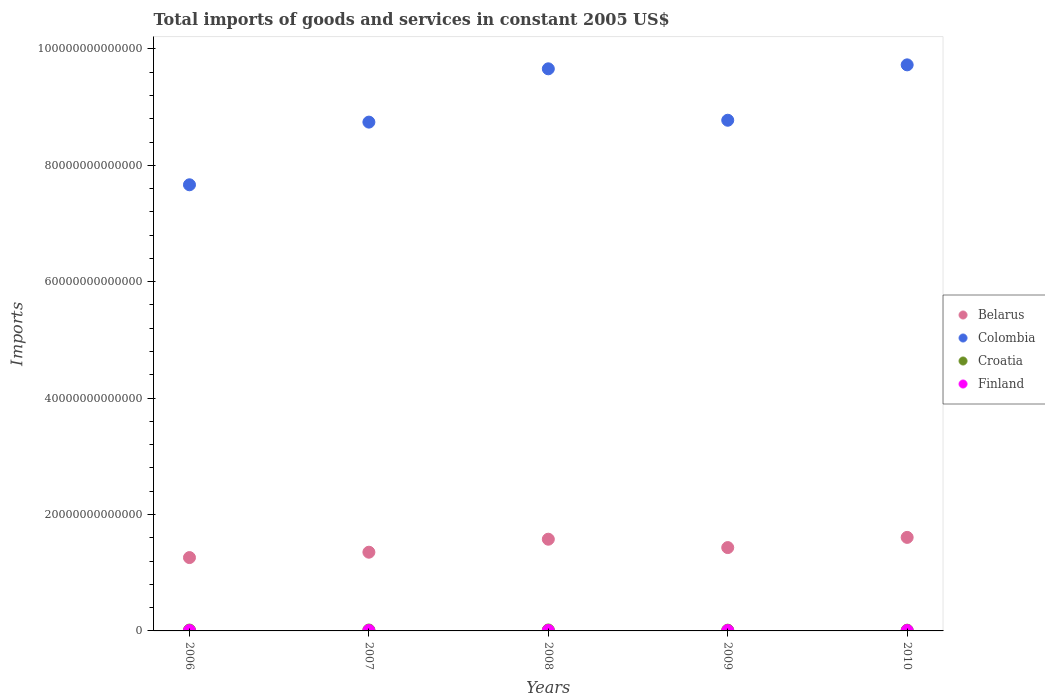What is the total imports of goods and services in Colombia in 2007?
Your answer should be very brief. 8.74e+13. Across all years, what is the maximum total imports of goods and services in Belarus?
Provide a short and direct response. 1.61e+13. Across all years, what is the minimum total imports of goods and services in Croatia?
Offer a very short reply. 1.25e+11. In which year was the total imports of goods and services in Croatia minimum?
Your response must be concise. 2010. What is the total total imports of goods and services in Finland in the graph?
Make the answer very short. 3.56e+11. What is the difference between the total imports of goods and services in Belarus in 2007 and that in 2009?
Offer a terse response. -7.94e+11. What is the difference between the total imports of goods and services in Croatia in 2010 and the total imports of goods and services in Finland in 2007?
Offer a very short reply. 5.19e+1. What is the average total imports of goods and services in Finland per year?
Offer a very short reply. 7.12e+1. In the year 2010, what is the difference between the total imports of goods and services in Belarus and total imports of goods and services in Colombia?
Give a very brief answer. -8.12e+13. In how many years, is the total imports of goods and services in Croatia greater than 68000000000000 US$?
Provide a succinct answer. 0. What is the ratio of the total imports of goods and services in Belarus in 2007 to that in 2010?
Your response must be concise. 0.84. Is the difference between the total imports of goods and services in Belarus in 2006 and 2008 greater than the difference between the total imports of goods and services in Colombia in 2006 and 2008?
Ensure brevity in your answer.  Yes. What is the difference between the highest and the second highest total imports of goods and services in Finland?
Keep it short and to the point. 5.80e+09. What is the difference between the highest and the lowest total imports of goods and services in Croatia?
Provide a succinct answer. 3.60e+1. Is the sum of the total imports of goods and services in Finland in 2006 and 2010 greater than the maximum total imports of goods and services in Croatia across all years?
Provide a succinct answer. No. Is it the case that in every year, the sum of the total imports of goods and services in Croatia and total imports of goods and services in Belarus  is greater than the total imports of goods and services in Colombia?
Give a very brief answer. No. Is the total imports of goods and services in Colombia strictly greater than the total imports of goods and services in Belarus over the years?
Keep it short and to the point. Yes. Is the total imports of goods and services in Croatia strictly less than the total imports of goods and services in Finland over the years?
Your answer should be very brief. No. How many years are there in the graph?
Keep it short and to the point. 5. What is the difference between two consecutive major ticks on the Y-axis?
Provide a succinct answer. 2.00e+13. Are the values on the major ticks of Y-axis written in scientific E-notation?
Your answer should be very brief. No. Does the graph contain grids?
Provide a succinct answer. No. What is the title of the graph?
Offer a terse response. Total imports of goods and services in constant 2005 US$. Does "Trinidad and Tobago" appear as one of the legend labels in the graph?
Offer a terse response. No. What is the label or title of the X-axis?
Your answer should be very brief. Years. What is the label or title of the Y-axis?
Provide a succinct answer. Imports. What is the Imports of Belarus in 2006?
Offer a very short reply. 1.26e+13. What is the Imports in Colombia in 2006?
Make the answer very short. 7.67e+13. What is the Imports of Croatia in 2006?
Offer a terse response. 1.46e+11. What is the Imports of Finland in 2006?
Offer a terse response. 6.82e+1. What is the Imports of Belarus in 2007?
Keep it short and to the point. 1.35e+13. What is the Imports in Colombia in 2007?
Your response must be concise. 8.74e+13. What is the Imports of Croatia in 2007?
Your answer should be compact. 1.55e+11. What is the Imports in Finland in 2007?
Your answer should be very brief. 7.32e+1. What is the Imports of Belarus in 2008?
Offer a terse response. 1.58e+13. What is the Imports of Colombia in 2008?
Offer a terse response. 9.66e+13. What is the Imports in Croatia in 2008?
Your answer should be very brief. 1.61e+11. What is the Imports of Finland in 2008?
Make the answer very short. 7.90e+1. What is the Imports of Belarus in 2009?
Ensure brevity in your answer.  1.43e+13. What is the Imports of Colombia in 2009?
Provide a short and direct response. 8.77e+13. What is the Imports of Croatia in 2009?
Provide a succinct answer. 1.28e+11. What is the Imports of Finland in 2009?
Make the answer very short. 6.57e+1. What is the Imports of Belarus in 2010?
Provide a short and direct response. 1.61e+13. What is the Imports in Colombia in 2010?
Ensure brevity in your answer.  9.73e+13. What is the Imports of Croatia in 2010?
Your response must be concise. 1.25e+11. What is the Imports of Finland in 2010?
Provide a succinct answer. 7.00e+1. Across all years, what is the maximum Imports in Belarus?
Make the answer very short. 1.61e+13. Across all years, what is the maximum Imports of Colombia?
Provide a succinct answer. 9.73e+13. Across all years, what is the maximum Imports in Croatia?
Ensure brevity in your answer.  1.61e+11. Across all years, what is the maximum Imports in Finland?
Your response must be concise. 7.90e+1. Across all years, what is the minimum Imports of Belarus?
Your answer should be very brief. 1.26e+13. Across all years, what is the minimum Imports in Colombia?
Offer a terse response. 7.67e+13. Across all years, what is the minimum Imports in Croatia?
Your answer should be very brief. 1.25e+11. Across all years, what is the minimum Imports of Finland?
Make the answer very short. 6.57e+1. What is the total Imports of Belarus in the graph?
Give a very brief answer. 7.23e+13. What is the total Imports in Colombia in the graph?
Provide a short and direct response. 4.46e+14. What is the total Imports in Croatia in the graph?
Your answer should be very brief. 7.16e+11. What is the total Imports in Finland in the graph?
Keep it short and to the point. 3.56e+11. What is the difference between the Imports in Belarus in 2006 and that in 2007?
Make the answer very short. -9.23e+11. What is the difference between the Imports in Colombia in 2006 and that in 2007?
Your answer should be very brief. -1.08e+13. What is the difference between the Imports in Croatia in 2006 and that in 2007?
Give a very brief answer. -8.89e+09. What is the difference between the Imports in Finland in 2006 and that in 2007?
Make the answer very short. -5.05e+09. What is the difference between the Imports in Belarus in 2006 and that in 2008?
Provide a succinct answer. -3.15e+12. What is the difference between the Imports of Colombia in 2006 and that in 2008?
Provide a succinct answer. -1.99e+13. What is the difference between the Imports in Croatia in 2006 and that in 2008?
Provide a succinct answer. -1.50e+1. What is the difference between the Imports of Finland in 2006 and that in 2008?
Give a very brief answer. -1.09e+1. What is the difference between the Imports of Belarus in 2006 and that in 2009?
Ensure brevity in your answer.  -1.72e+12. What is the difference between the Imports of Colombia in 2006 and that in 2009?
Keep it short and to the point. -1.11e+13. What is the difference between the Imports in Croatia in 2006 and that in 2009?
Provide a short and direct response. 1.78e+1. What is the difference between the Imports in Finland in 2006 and that in 2009?
Your answer should be compact. 2.47e+09. What is the difference between the Imports in Belarus in 2006 and that in 2010?
Give a very brief answer. -3.47e+12. What is the difference between the Imports of Colombia in 2006 and that in 2010?
Offer a very short reply. -2.06e+13. What is the difference between the Imports of Croatia in 2006 and that in 2010?
Your response must be concise. 2.10e+1. What is the difference between the Imports in Finland in 2006 and that in 2010?
Make the answer very short. -1.80e+09. What is the difference between the Imports of Belarus in 2007 and that in 2008?
Offer a very short reply. -2.23e+12. What is the difference between the Imports in Colombia in 2007 and that in 2008?
Your answer should be very brief. -9.16e+12. What is the difference between the Imports in Croatia in 2007 and that in 2008?
Give a very brief answer. -6.14e+09. What is the difference between the Imports of Finland in 2007 and that in 2008?
Ensure brevity in your answer.  -5.80e+09. What is the difference between the Imports of Belarus in 2007 and that in 2009?
Make the answer very short. -7.94e+11. What is the difference between the Imports in Colombia in 2007 and that in 2009?
Provide a short and direct response. -3.22e+11. What is the difference between the Imports of Croatia in 2007 and that in 2009?
Your answer should be compact. 2.67e+1. What is the difference between the Imports in Finland in 2007 and that in 2009?
Ensure brevity in your answer.  7.52e+09. What is the difference between the Imports in Belarus in 2007 and that in 2010?
Offer a very short reply. -2.54e+12. What is the difference between the Imports of Colombia in 2007 and that in 2010?
Provide a succinct answer. -9.84e+12. What is the difference between the Imports of Croatia in 2007 and that in 2010?
Your response must be concise. 2.99e+1. What is the difference between the Imports of Finland in 2007 and that in 2010?
Your answer should be compact. 3.24e+09. What is the difference between the Imports of Belarus in 2008 and that in 2009?
Ensure brevity in your answer.  1.44e+12. What is the difference between the Imports of Colombia in 2008 and that in 2009?
Keep it short and to the point. 8.84e+12. What is the difference between the Imports of Croatia in 2008 and that in 2009?
Your answer should be very brief. 3.29e+1. What is the difference between the Imports of Finland in 2008 and that in 2009?
Ensure brevity in your answer.  1.33e+1. What is the difference between the Imports in Belarus in 2008 and that in 2010?
Offer a very short reply. -3.13e+11. What is the difference between the Imports in Colombia in 2008 and that in 2010?
Provide a succinct answer. -6.80e+11. What is the difference between the Imports of Croatia in 2008 and that in 2010?
Provide a short and direct response. 3.60e+1. What is the difference between the Imports of Finland in 2008 and that in 2010?
Offer a terse response. 9.05e+09. What is the difference between the Imports of Belarus in 2009 and that in 2010?
Provide a short and direct response. -1.75e+12. What is the difference between the Imports in Colombia in 2009 and that in 2010?
Your answer should be compact. -9.52e+12. What is the difference between the Imports of Croatia in 2009 and that in 2010?
Ensure brevity in your answer.  3.17e+09. What is the difference between the Imports of Finland in 2009 and that in 2010?
Make the answer very short. -4.27e+09. What is the difference between the Imports in Belarus in 2006 and the Imports in Colombia in 2007?
Offer a very short reply. -7.48e+13. What is the difference between the Imports of Belarus in 2006 and the Imports of Croatia in 2007?
Provide a succinct answer. 1.24e+13. What is the difference between the Imports in Belarus in 2006 and the Imports in Finland in 2007?
Ensure brevity in your answer.  1.25e+13. What is the difference between the Imports of Colombia in 2006 and the Imports of Croatia in 2007?
Give a very brief answer. 7.65e+13. What is the difference between the Imports of Colombia in 2006 and the Imports of Finland in 2007?
Provide a succinct answer. 7.66e+13. What is the difference between the Imports of Croatia in 2006 and the Imports of Finland in 2007?
Your answer should be very brief. 7.30e+1. What is the difference between the Imports in Belarus in 2006 and the Imports in Colombia in 2008?
Keep it short and to the point. -8.40e+13. What is the difference between the Imports of Belarus in 2006 and the Imports of Croatia in 2008?
Your answer should be very brief. 1.24e+13. What is the difference between the Imports of Belarus in 2006 and the Imports of Finland in 2008?
Provide a succinct answer. 1.25e+13. What is the difference between the Imports in Colombia in 2006 and the Imports in Croatia in 2008?
Offer a very short reply. 7.65e+13. What is the difference between the Imports of Colombia in 2006 and the Imports of Finland in 2008?
Provide a succinct answer. 7.66e+13. What is the difference between the Imports in Croatia in 2006 and the Imports in Finland in 2008?
Keep it short and to the point. 6.71e+1. What is the difference between the Imports in Belarus in 2006 and the Imports in Colombia in 2009?
Your answer should be very brief. -7.51e+13. What is the difference between the Imports of Belarus in 2006 and the Imports of Croatia in 2009?
Offer a terse response. 1.25e+13. What is the difference between the Imports in Belarus in 2006 and the Imports in Finland in 2009?
Offer a very short reply. 1.25e+13. What is the difference between the Imports of Colombia in 2006 and the Imports of Croatia in 2009?
Provide a succinct answer. 7.65e+13. What is the difference between the Imports in Colombia in 2006 and the Imports in Finland in 2009?
Make the answer very short. 7.66e+13. What is the difference between the Imports of Croatia in 2006 and the Imports of Finland in 2009?
Provide a succinct answer. 8.05e+1. What is the difference between the Imports of Belarus in 2006 and the Imports of Colombia in 2010?
Offer a terse response. -8.47e+13. What is the difference between the Imports in Belarus in 2006 and the Imports in Croatia in 2010?
Your answer should be compact. 1.25e+13. What is the difference between the Imports in Belarus in 2006 and the Imports in Finland in 2010?
Make the answer very short. 1.25e+13. What is the difference between the Imports in Colombia in 2006 and the Imports in Croatia in 2010?
Give a very brief answer. 7.65e+13. What is the difference between the Imports in Colombia in 2006 and the Imports in Finland in 2010?
Ensure brevity in your answer.  7.66e+13. What is the difference between the Imports in Croatia in 2006 and the Imports in Finland in 2010?
Ensure brevity in your answer.  7.62e+1. What is the difference between the Imports of Belarus in 2007 and the Imports of Colombia in 2008?
Your answer should be very brief. -8.31e+13. What is the difference between the Imports in Belarus in 2007 and the Imports in Croatia in 2008?
Give a very brief answer. 1.34e+13. What is the difference between the Imports in Belarus in 2007 and the Imports in Finland in 2008?
Give a very brief answer. 1.34e+13. What is the difference between the Imports in Colombia in 2007 and the Imports in Croatia in 2008?
Your response must be concise. 8.73e+13. What is the difference between the Imports in Colombia in 2007 and the Imports in Finland in 2008?
Provide a succinct answer. 8.73e+13. What is the difference between the Imports of Croatia in 2007 and the Imports of Finland in 2008?
Give a very brief answer. 7.60e+1. What is the difference between the Imports in Belarus in 2007 and the Imports in Colombia in 2009?
Offer a very short reply. -7.42e+13. What is the difference between the Imports of Belarus in 2007 and the Imports of Croatia in 2009?
Provide a short and direct response. 1.34e+13. What is the difference between the Imports in Belarus in 2007 and the Imports in Finland in 2009?
Provide a short and direct response. 1.35e+13. What is the difference between the Imports of Colombia in 2007 and the Imports of Croatia in 2009?
Keep it short and to the point. 8.73e+13. What is the difference between the Imports in Colombia in 2007 and the Imports in Finland in 2009?
Ensure brevity in your answer.  8.74e+13. What is the difference between the Imports of Croatia in 2007 and the Imports of Finland in 2009?
Make the answer very short. 8.94e+1. What is the difference between the Imports of Belarus in 2007 and the Imports of Colombia in 2010?
Give a very brief answer. -8.37e+13. What is the difference between the Imports in Belarus in 2007 and the Imports in Croatia in 2010?
Provide a succinct answer. 1.34e+13. What is the difference between the Imports in Belarus in 2007 and the Imports in Finland in 2010?
Make the answer very short. 1.35e+13. What is the difference between the Imports of Colombia in 2007 and the Imports of Croatia in 2010?
Provide a succinct answer. 8.73e+13. What is the difference between the Imports in Colombia in 2007 and the Imports in Finland in 2010?
Keep it short and to the point. 8.74e+13. What is the difference between the Imports of Croatia in 2007 and the Imports of Finland in 2010?
Your answer should be compact. 8.51e+1. What is the difference between the Imports of Belarus in 2008 and the Imports of Colombia in 2009?
Keep it short and to the point. -7.20e+13. What is the difference between the Imports in Belarus in 2008 and the Imports in Croatia in 2009?
Offer a very short reply. 1.56e+13. What is the difference between the Imports of Belarus in 2008 and the Imports of Finland in 2009?
Your answer should be compact. 1.57e+13. What is the difference between the Imports in Colombia in 2008 and the Imports in Croatia in 2009?
Your answer should be very brief. 9.65e+13. What is the difference between the Imports of Colombia in 2008 and the Imports of Finland in 2009?
Make the answer very short. 9.65e+13. What is the difference between the Imports in Croatia in 2008 and the Imports in Finland in 2009?
Your answer should be compact. 9.55e+1. What is the difference between the Imports in Belarus in 2008 and the Imports in Colombia in 2010?
Offer a very short reply. -8.15e+13. What is the difference between the Imports of Belarus in 2008 and the Imports of Croatia in 2010?
Your answer should be compact. 1.56e+13. What is the difference between the Imports in Belarus in 2008 and the Imports in Finland in 2010?
Provide a short and direct response. 1.57e+13. What is the difference between the Imports in Colombia in 2008 and the Imports in Croatia in 2010?
Your answer should be very brief. 9.65e+13. What is the difference between the Imports in Colombia in 2008 and the Imports in Finland in 2010?
Your response must be concise. 9.65e+13. What is the difference between the Imports of Croatia in 2008 and the Imports of Finland in 2010?
Offer a very short reply. 9.12e+1. What is the difference between the Imports of Belarus in 2009 and the Imports of Colombia in 2010?
Your answer should be very brief. -8.29e+13. What is the difference between the Imports in Belarus in 2009 and the Imports in Croatia in 2010?
Your answer should be compact. 1.42e+13. What is the difference between the Imports of Belarus in 2009 and the Imports of Finland in 2010?
Keep it short and to the point. 1.42e+13. What is the difference between the Imports in Colombia in 2009 and the Imports in Croatia in 2010?
Your answer should be compact. 8.76e+13. What is the difference between the Imports of Colombia in 2009 and the Imports of Finland in 2010?
Offer a very short reply. 8.77e+13. What is the difference between the Imports of Croatia in 2009 and the Imports of Finland in 2010?
Provide a succinct answer. 5.84e+1. What is the average Imports in Belarus per year?
Ensure brevity in your answer.  1.45e+13. What is the average Imports in Colombia per year?
Keep it short and to the point. 8.91e+13. What is the average Imports of Croatia per year?
Your answer should be compact. 1.43e+11. What is the average Imports of Finland per year?
Provide a short and direct response. 7.12e+1. In the year 2006, what is the difference between the Imports in Belarus and Imports in Colombia?
Provide a short and direct response. -6.41e+13. In the year 2006, what is the difference between the Imports in Belarus and Imports in Croatia?
Your response must be concise. 1.25e+13. In the year 2006, what is the difference between the Imports of Belarus and Imports of Finland?
Provide a succinct answer. 1.25e+13. In the year 2006, what is the difference between the Imports in Colombia and Imports in Croatia?
Provide a short and direct response. 7.65e+13. In the year 2006, what is the difference between the Imports in Colombia and Imports in Finland?
Keep it short and to the point. 7.66e+13. In the year 2006, what is the difference between the Imports of Croatia and Imports of Finland?
Keep it short and to the point. 7.80e+1. In the year 2007, what is the difference between the Imports of Belarus and Imports of Colombia?
Offer a terse response. -7.39e+13. In the year 2007, what is the difference between the Imports in Belarus and Imports in Croatia?
Provide a succinct answer. 1.34e+13. In the year 2007, what is the difference between the Imports of Belarus and Imports of Finland?
Ensure brevity in your answer.  1.35e+13. In the year 2007, what is the difference between the Imports in Colombia and Imports in Croatia?
Ensure brevity in your answer.  8.73e+13. In the year 2007, what is the difference between the Imports in Colombia and Imports in Finland?
Give a very brief answer. 8.73e+13. In the year 2007, what is the difference between the Imports of Croatia and Imports of Finland?
Provide a short and direct response. 8.18e+1. In the year 2008, what is the difference between the Imports in Belarus and Imports in Colombia?
Keep it short and to the point. -8.08e+13. In the year 2008, what is the difference between the Imports of Belarus and Imports of Croatia?
Make the answer very short. 1.56e+13. In the year 2008, what is the difference between the Imports in Belarus and Imports in Finland?
Your answer should be very brief. 1.57e+13. In the year 2008, what is the difference between the Imports of Colombia and Imports of Croatia?
Make the answer very short. 9.64e+13. In the year 2008, what is the difference between the Imports in Colombia and Imports in Finland?
Give a very brief answer. 9.65e+13. In the year 2008, what is the difference between the Imports of Croatia and Imports of Finland?
Your answer should be very brief. 8.22e+1. In the year 2009, what is the difference between the Imports of Belarus and Imports of Colombia?
Your answer should be very brief. -7.34e+13. In the year 2009, what is the difference between the Imports of Belarus and Imports of Croatia?
Provide a short and direct response. 1.42e+13. In the year 2009, what is the difference between the Imports in Belarus and Imports in Finland?
Give a very brief answer. 1.43e+13. In the year 2009, what is the difference between the Imports of Colombia and Imports of Croatia?
Your answer should be very brief. 8.76e+13. In the year 2009, what is the difference between the Imports of Colombia and Imports of Finland?
Offer a terse response. 8.77e+13. In the year 2009, what is the difference between the Imports in Croatia and Imports in Finland?
Ensure brevity in your answer.  6.26e+1. In the year 2010, what is the difference between the Imports in Belarus and Imports in Colombia?
Ensure brevity in your answer.  -8.12e+13. In the year 2010, what is the difference between the Imports in Belarus and Imports in Croatia?
Keep it short and to the point. 1.59e+13. In the year 2010, what is the difference between the Imports in Belarus and Imports in Finland?
Make the answer very short. 1.60e+13. In the year 2010, what is the difference between the Imports of Colombia and Imports of Croatia?
Give a very brief answer. 9.71e+13. In the year 2010, what is the difference between the Imports of Colombia and Imports of Finland?
Give a very brief answer. 9.72e+13. In the year 2010, what is the difference between the Imports of Croatia and Imports of Finland?
Offer a very short reply. 5.52e+1. What is the ratio of the Imports in Belarus in 2006 to that in 2007?
Provide a short and direct response. 0.93. What is the ratio of the Imports of Colombia in 2006 to that in 2007?
Your answer should be compact. 0.88. What is the ratio of the Imports of Croatia in 2006 to that in 2007?
Your answer should be very brief. 0.94. What is the ratio of the Imports in Finland in 2006 to that in 2007?
Offer a very short reply. 0.93. What is the ratio of the Imports in Belarus in 2006 to that in 2008?
Your answer should be compact. 0.8. What is the ratio of the Imports in Colombia in 2006 to that in 2008?
Offer a terse response. 0.79. What is the ratio of the Imports of Croatia in 2006 to that in 2008?
Your answer should be very brief. 0.91. What is the ratio of the Imports in Finland in 2006 to that in 2008?
Offer a very short reply. 0.86. What is the ratio of the Imports in Belarus in 2006 to that in 2009?
Provide a succinct answer. 0.88. What is the ratio of the Imports in Colombia in 2006 to that in 2009?
Make the answer very short. 0.87. What is the ratio of the Imports in Croatia in 2006 to that in 2009?
Your response must be concise. 1.14. What is the ratio of the Imports of Finland in 2006 to that in 2009?
Offer a very short reply. 1.04. What is the ratio of the Imports of Belarus in 2006 to that in 2010?
Ensure brevity in your answer.  0.78. What is the ratio of the Imports of Colombia in 2006 to that in 2010?
Your answer should be compact. 0.79. What is the ratio of the Imports of Croatia in 2006 to that in 2010?
Provide a short and direct response. 1.17. What is the ratio of the Imports in Finland in 2006 to that in 2010?
Your answer should be compact. 0.97. What is the ratio of the Imports in Belarus in 2007 to that in 2008?
Your answer should be compact. 0.86. What is the ratio of the Imports in Colombia in 2007 to that in 2008?
Offer a terse response. 0.91. What is the ratio of the Imports in Croatia in 2007 to that in 2008?
Offer a very short reply. 0.96. What is the ratio of the Imports of Finland in 2007 to that in 2008?
Offer a terse response. 0.93. What is the ratio of the Imports of Belarus in 2007 to that in 2009?
Give a very brief answer. 0.94. What is the ratio of the Imports in Colombia in 2007 to that in 2009?
Keep it short and to the point. 1. What is the ratio of the Imports in Croatia in 2007 to that in 2009?
Your response must be concise. 1.21. What is the ratio of the Imports in Finland in 2007 to that in 2009?
Offer a very short reply. 1.11. What is the ratio of the Imports in Belarus in 2007 to that in 2010?
Your answer should be very brief. 0.84. What is the ratio of the Imports in Colombia in 2007 to that in 2010?
Offer a very short reply. 0.9. What is the ratio of the Imports of Croatia in 2007 to that in 2010?
Your response must be concise. 1.24. What is the ratio of the Imports of Finland in 2007 to that in 2010?
Your response must be concise. 1.05. What is the ratio of the Imports of Belarus in 2008 to that in 2009?
Your answer should be very brief. 1.1. What is the ratio of the Imports of Colombia in 2008 to that in 2009?
Provide a short and direct response. 1.1. What is the ratio of the Imports of Croatia in 2008 to that in 2009?
Give a very brief answer. 1.26. What is the ratio of the Imports of Finland in 2008 to that in 2009?
Your answer should be compact. 1.2. What is the ratio of the Imports in Belarus in 2008 to that in 2010?
Make the answer very short. 0.98. What is the ratio of the Imports in Colombia in 2008 to that in 2010?
Give a very brief answer. 0.99. What is the ratio of the Imports in Croatia in 2008 to that in 2010?
Keep it short and to the point. 1.29. What is the ratio of the Imports of Finland in 2008 to that in 2010?
Your answer should be very brief. 1.13. What is the ratio of the Imports of Belarus in 2009 to that in 2010?
Offer a very short reply. 0.89. What is the ratio of the Imports of Colombia in 2009 to that in 2010?
Provide a short and direct response. 0.9. What is the ratio of the Imports of Croatia in 2009 to that in 2010?
Provide a succinct answer. 1.03. What is the ratio of the Imports in Finland in 2009 to that in 2010?
Your answer should be compact. 0.94. What is the difference between the highest and the second highest Imports of Belarus?
Your answer should be compact. 3.13e+11. What is the difference between the highest and the second highest Imports of Colombia?
Your answer should be very brief. 6.80e+11. What is the difference between the highest and the second highest Imports of Croatia?
Offer a very short reply. 6.14e+09. What is the difference between the highest and the second highest Imports of Finland?
Offer a terse response. 5.80e+09. What is the difference between the highest and the lowest Imports in Belarus?
Give a very brief answer. 3.47e+12. What is the difference between the highest and the lowest Imports in Colombia?
Ensure brevity in your answer.  2.06e+13. What is the difference between the highest and the lowest Imports in Croatia?
Your answer should be compact. 3.60e+1. What is the difference between the highest and the lowest Imports in Finland?
Your response must be concise. 1.33e+1. 